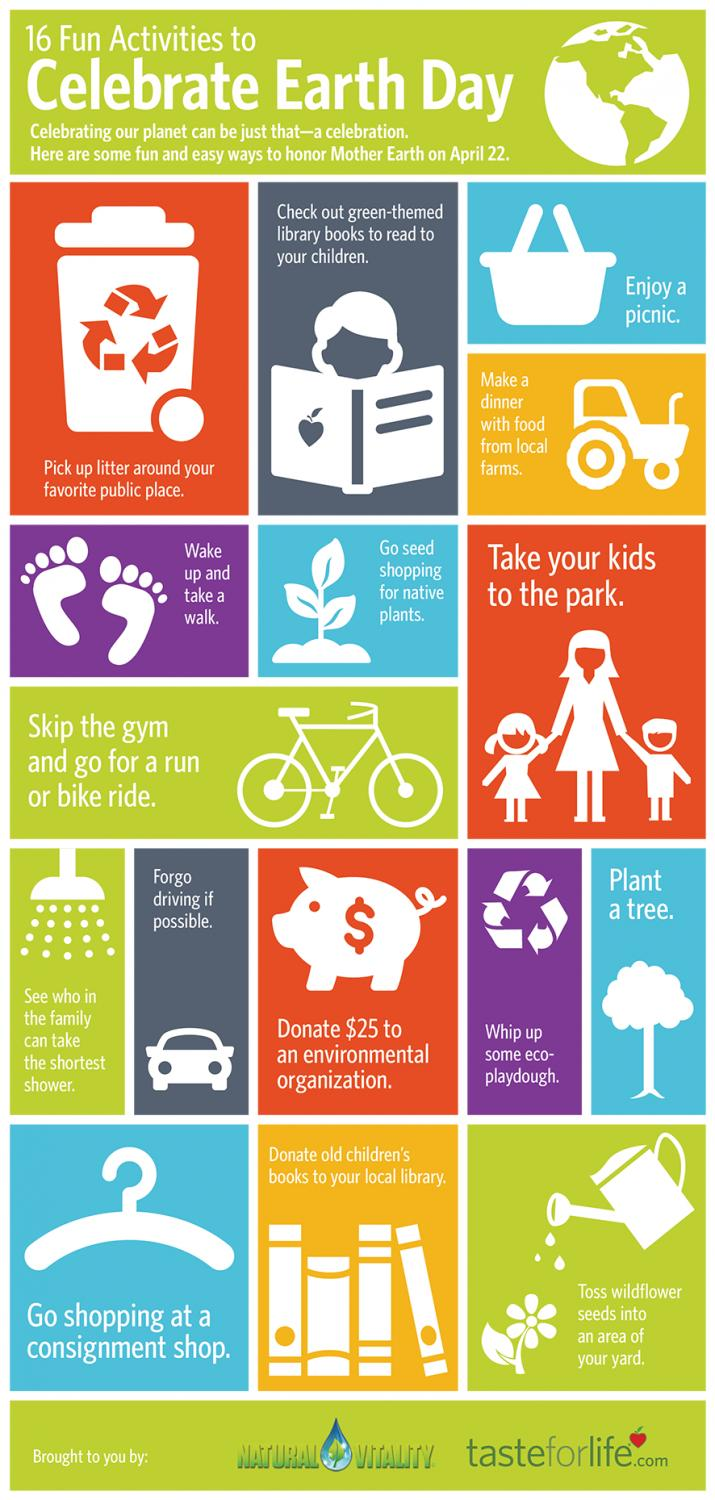List a handful of essential elements in this visual. Earth Day is celebrated on April 22nd every year. On this day, people around the world come together to show their support for environmental protection and sustainability. One of the activities that people celebrate on Earth Day is going seed shopping for native plants. This is the sixth activity to celebrate on Earth Day. By participating in this activity, individuals can help to restore and protect the natural habitats of plants and animals, and contribute to a healthier and more sustainable planet. Earth Day is a celebration of the planet we call home, and there are many activities that people do to mark the occasion. One of the fifth activity to celebrate on Earth Day is to wake up and take a walk outside. This simple act not only helps to improve one's physical health, but it also helps to connect with the natural world and appreciate the beauty of the planet we live on. Earth Day is celebrated annually on April 22nd, and one of the activities that is traditionally celebrated on this day is enjoying a dinner made with foods sourced from local farms. This practice is considered an important part of Earth Day celebrations because it not only supports the local agricultural community, but also reduces the carbon footprint associated with transporting food over long distances. Earth Day is celebrated with various activities, and picnicking is one of the third activity that is enjoyed by many people. 